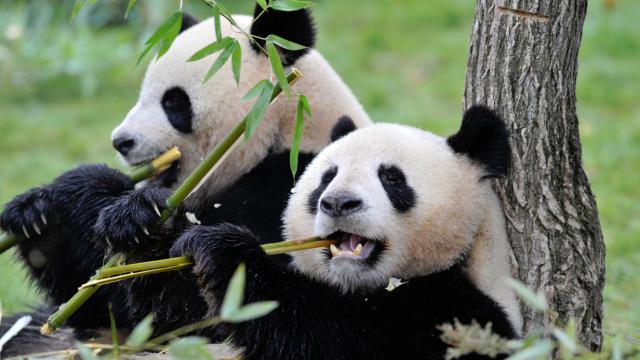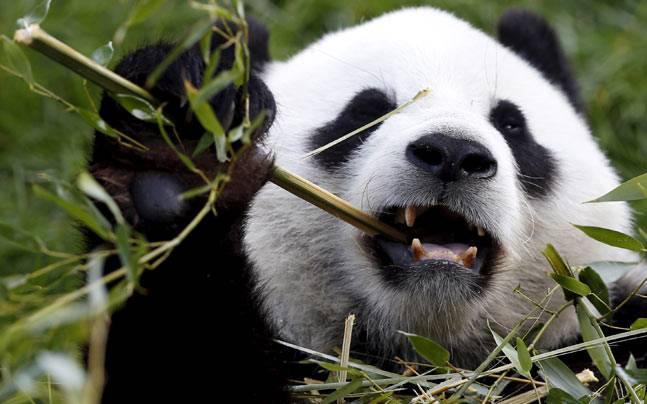The first image is the image on the left, the second image is the image on the right. Analyze the images presented: Is the assertion "There are four pandas" valid? Answer yes or no. No. The first image is the image on the left, the second image is the image on the right. Assess this claim about the two images: "One image shows two pandas, and the one on the left is standing on a log platform with an arm around the back-turned panda on the right.". Correct or not? Answer yes or no. No. 